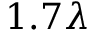<formula> <loc_0><loc_0><loc_500><loc_500>1 . 7 \lambda</formula> 